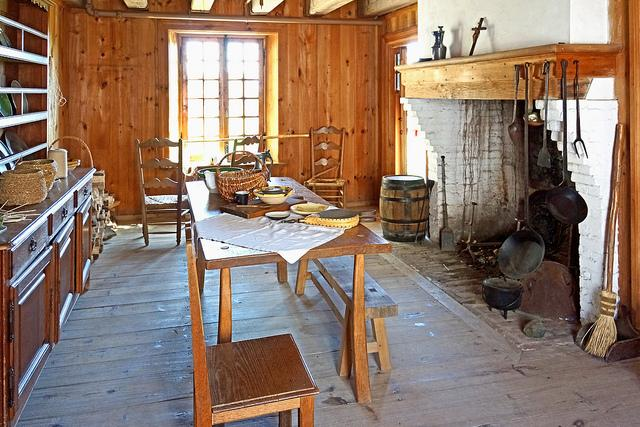What does the item hanging on the wall and closest to the broom look like? pitchfork 